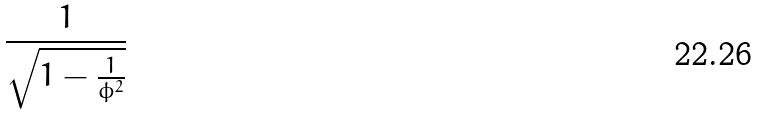Convert formula to latex. <formula><loc_0><loc_0><loc_500><loc_500>\frac { 1 } { \sqrt { 1 - \frac { 1 } { \phi ^ { 2 } } } }</formula> 